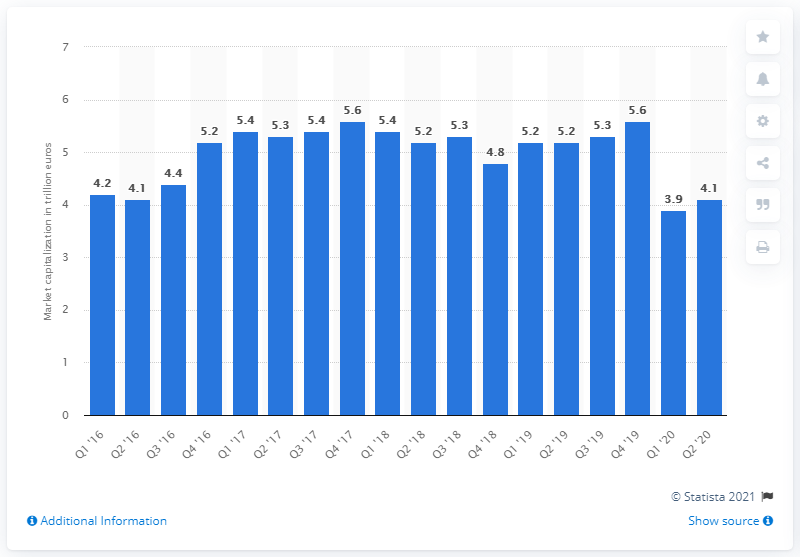Point out several critical features in this image. In the second quarter of 2020, the market capitalization of the top 100 global banks was 4.1 trillion dollars. 